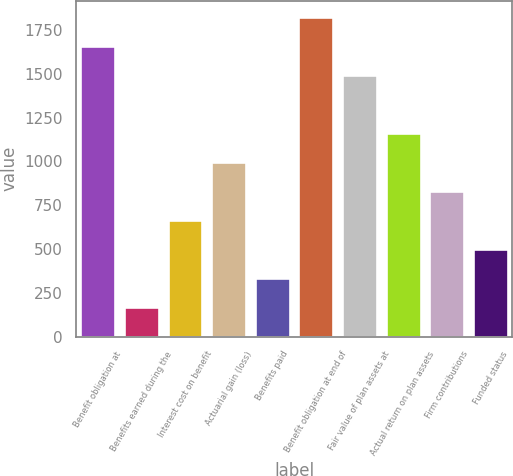Convert chart. <chart><loc_0><loc_0><loc_500><loc_500><bar_chart><fcel>Benefit obligation at<fcel>Benefits earned during the<fcel>Interest cost on benefit<fcel>Actuarial gain (loss)<fcel>Benefits paid<fcel>Benefit obligation at end of<fcel>Fair value of plan assets at<fcel>Actual return on plan assets<fcel>Firm contributions<fcel>Funded status<nl><fcel>1659<fcel>170.4<fcel>666.6<fcel>997.4<fcel>335.8<fcel>1824.4<fcel>1493.6<fcel>1162.8<fcel>832<fcel>501.2<nl></chart> 